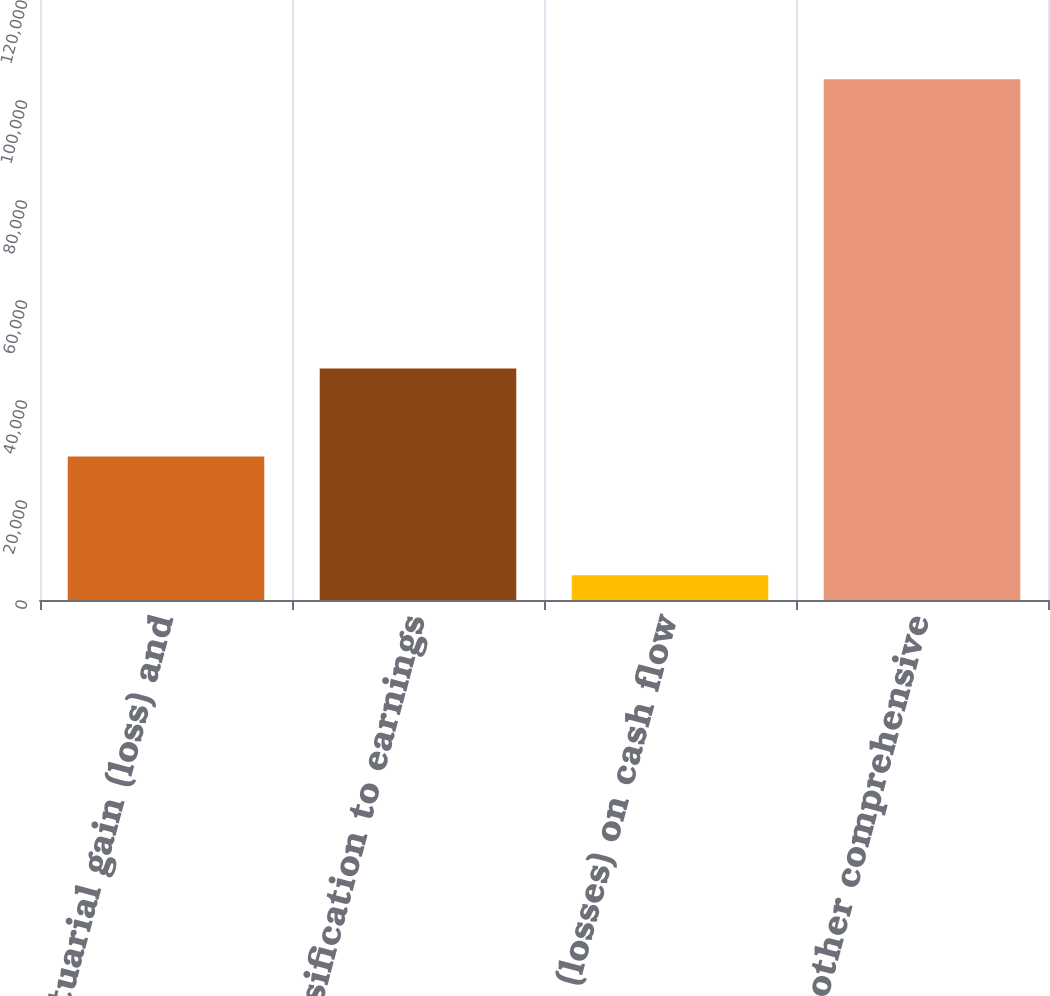Convert chart. <chart><loc_0><loc_0><loc_500><loc_500><bar_chart><fcel>Net actuarial gain (loss) and<fcel>Reclassification to earnings<fcel>Gains (losses) on cash flow<fcel>Total other comprehensive<nl><fcel>28718<fcel>46305<fcel>4931<fcel>104142<nl></chart> 